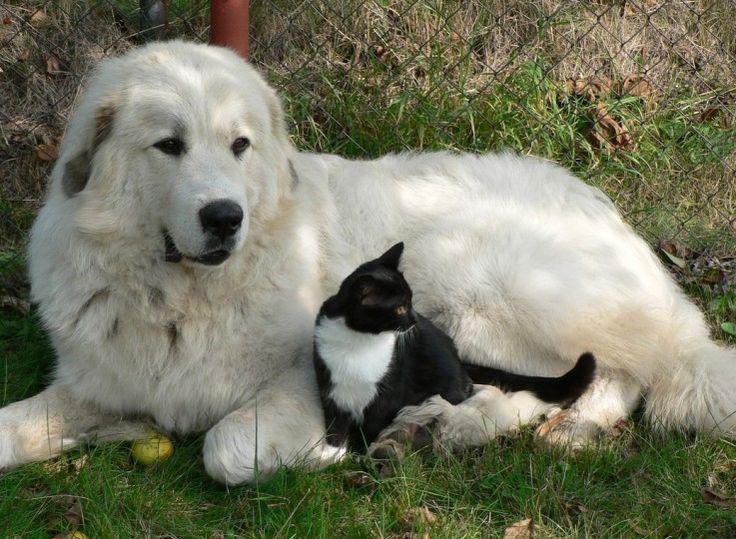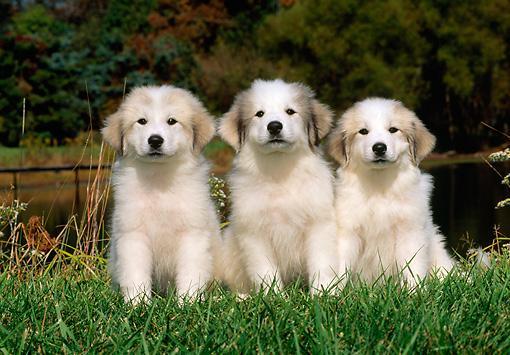The first image is the image on the left, the second image is the image on the right. Analyze the images presented: Is the assertion "There are exactly four dogs." valid? Answer yes or no. Yes. The first image is the image on the left, the second image is the image on the right. Evaluate the accuracy of this statement regarding the images: "The combined images contain a total of four dogs, including a row of three dogs posed side-by-side.". Is it true? Answer yes or no. Yes. 